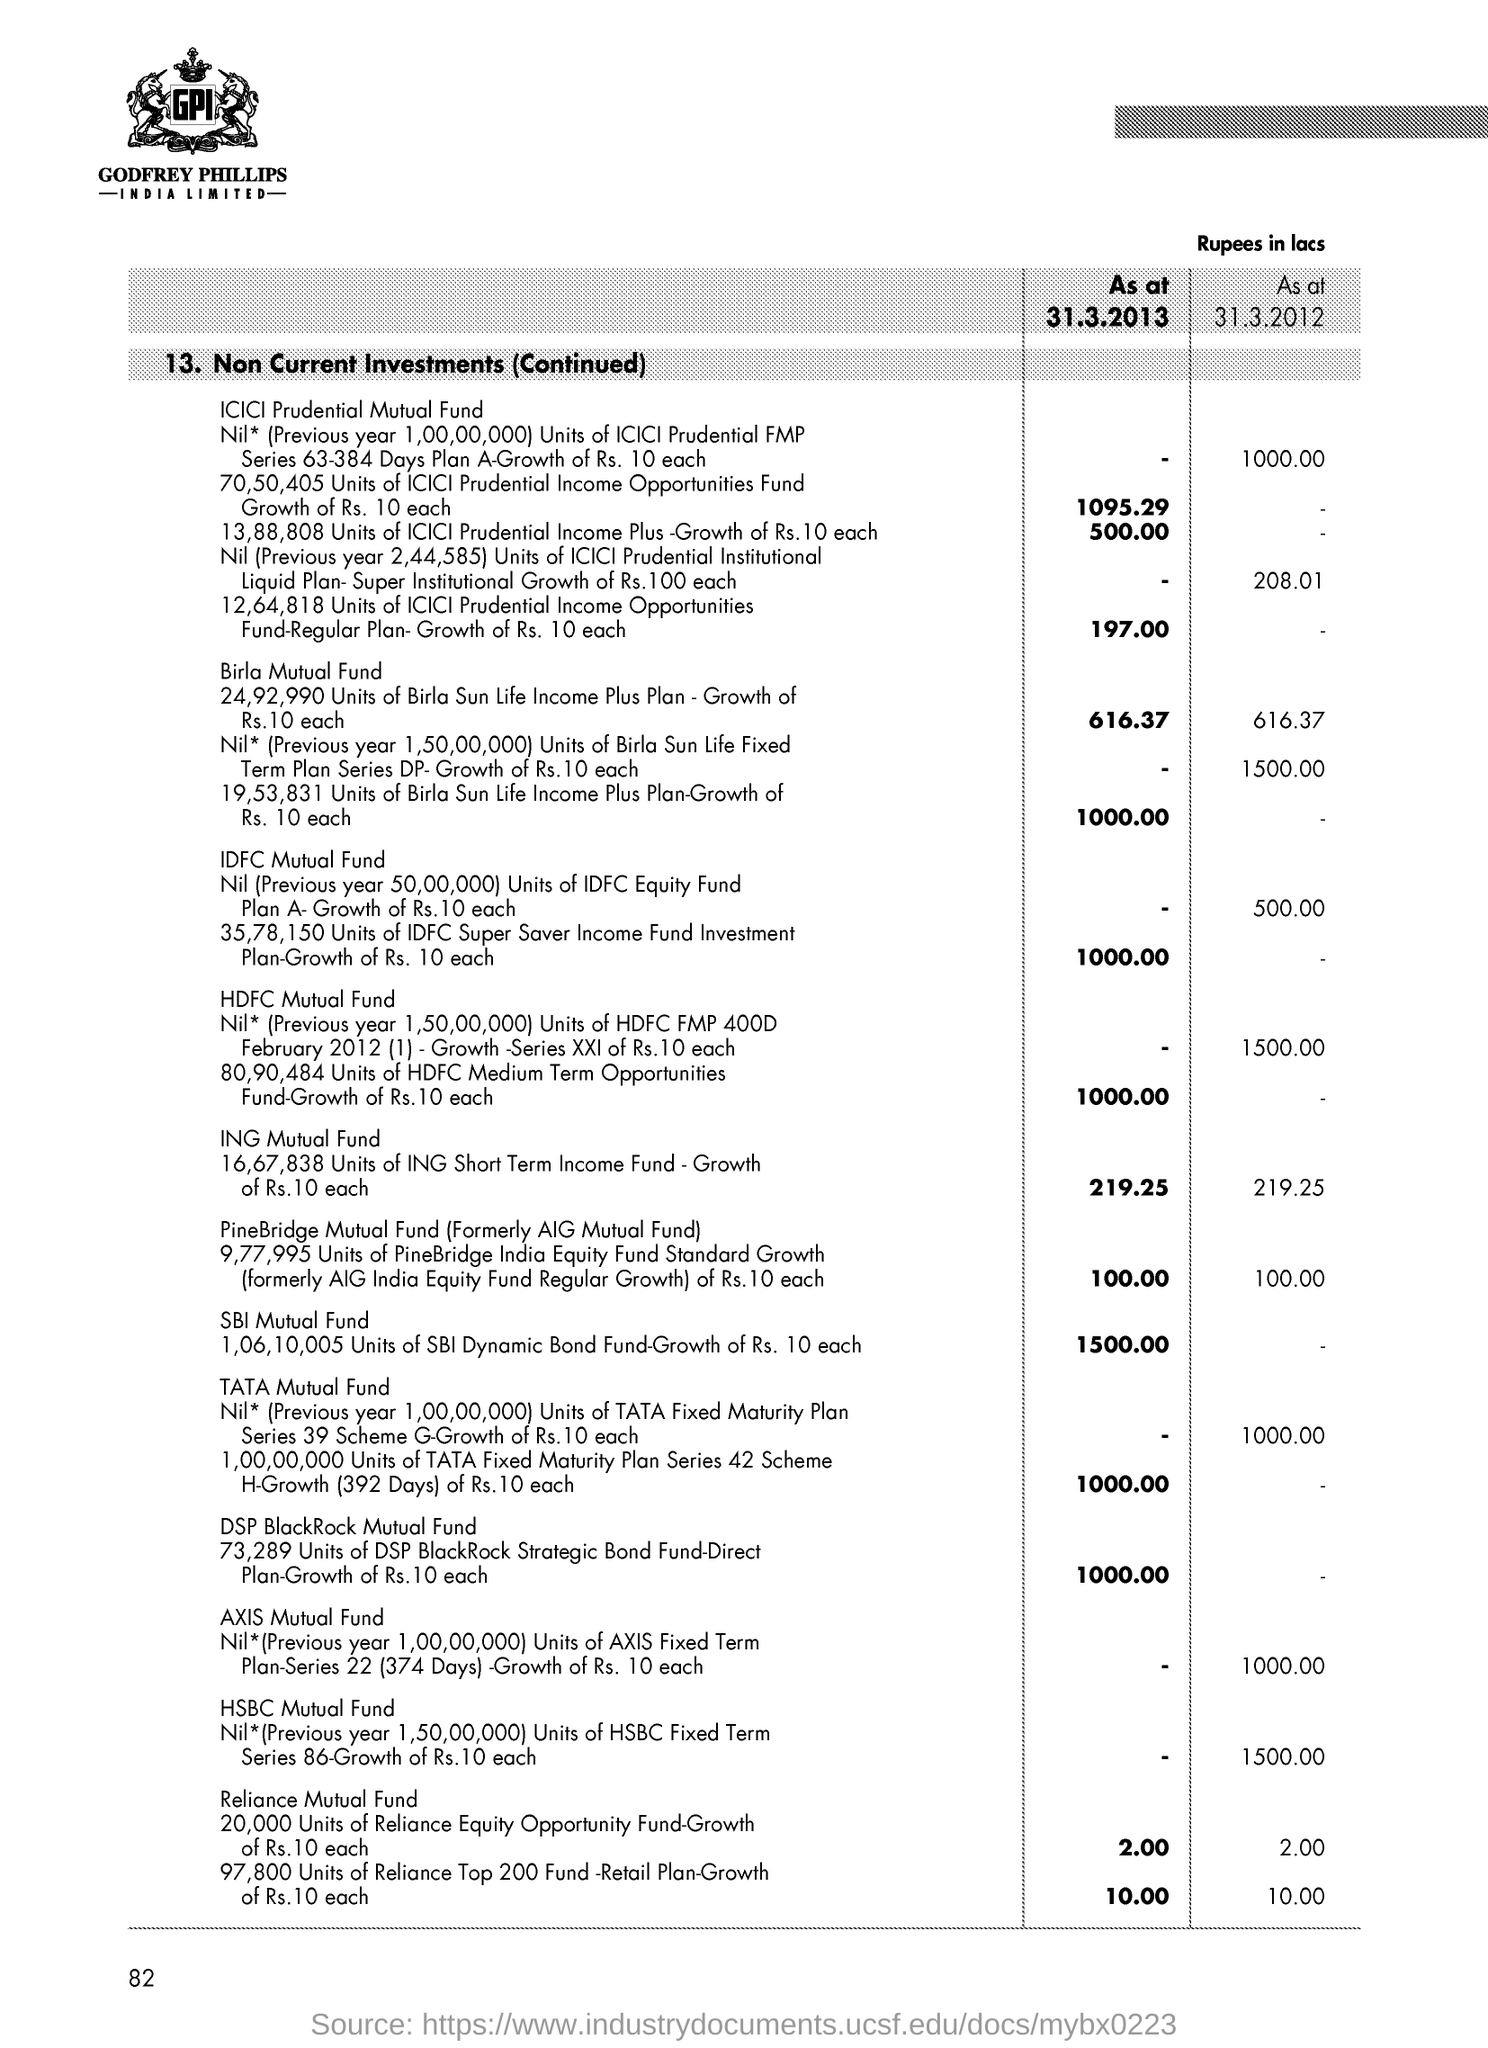Identify some key points in this picture. The page number is 82. 